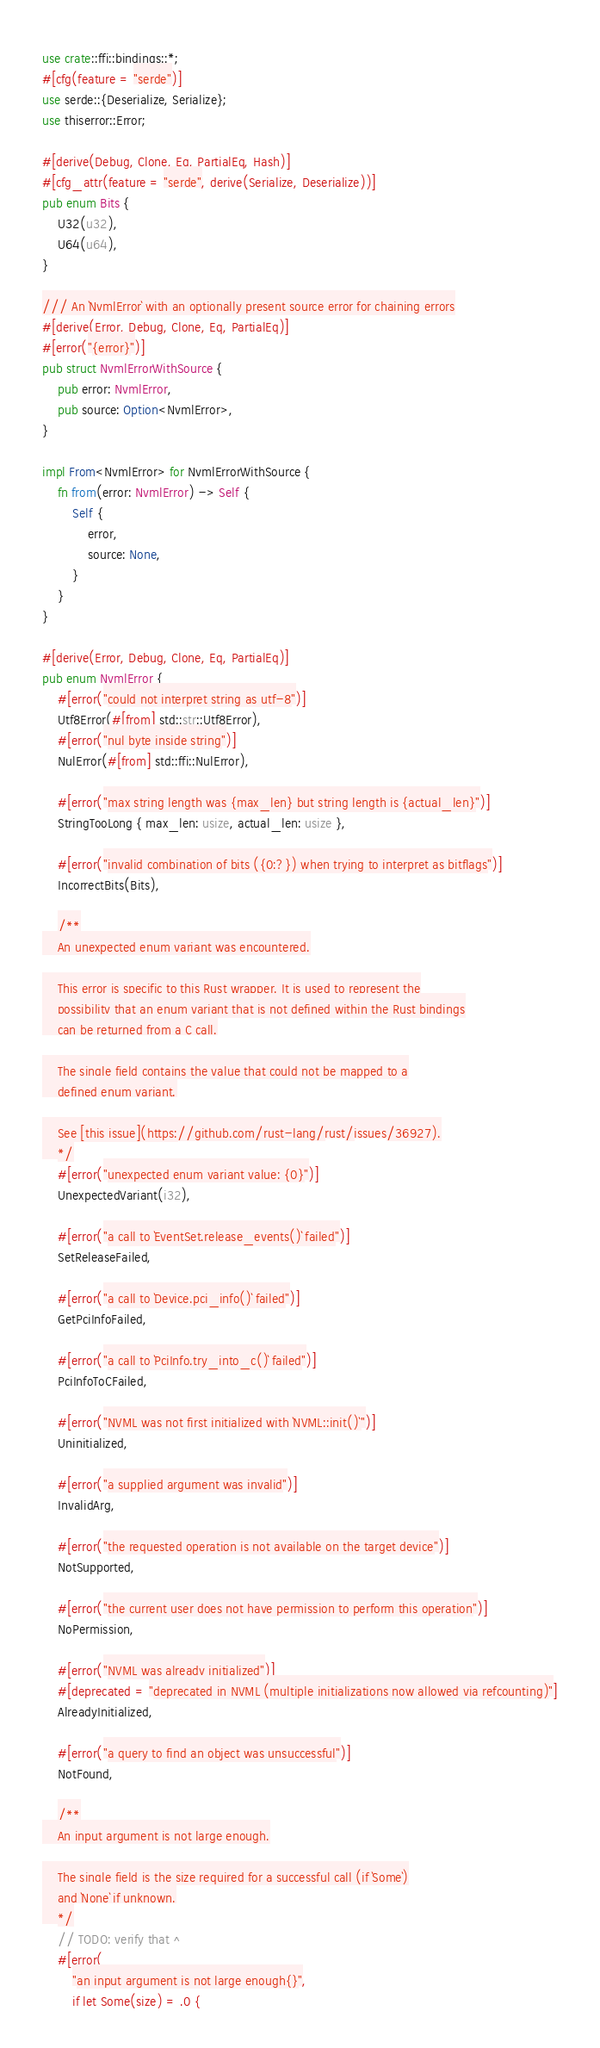Convert code to text. <code><loc_0><loc_0><loc_500><loc_500><_Rust_>use crate::ffi::bindings::*;
#[cfg(feature = "serde")]
use serde::{Deserialize, Serialize};
use thiserror::Error;

#[derive(Debug, Clone, Eq, PartialEq, Hash)]
#[cfg_attr(feature = "serde", derive(Serialize, Deserialize))]
pub enum Bits {
    U32(u32),
    U64(u64),
}

/// An `NvmlError` with an optionally present source error for chaining errors
#[derive(Error, Debug, Clone, Eq, PartialEq)]
#[error("{error}")]
pub struct NvmlErrorWithSource {
    pub error: NvmlError,
    pub source: Option<NvmlError>,
}

impl From<NvmlError> for NvmlErrorWithSource {
    fn from(error: NvmlError) -> Self {
        Self {
            error,
            source: None,
        }
    }
}

#[derive(Error, Debug, Clone, Eq, PartialEq)]
pub enum NvmlError {
    #[error("could not interpret string as utf-8")]
    Utf8Error(#[from] std::str::Utf8Error),
    #[error("nul byte inside string")]
    NulError(#[from] std::ffi::NulError),

    #[error("max string length was {max_len} but string length is {actual_len}")]
    StringTooLong { max_len: usize, actual_len: usize },

    #[error("invalid combination of bits ({0:?}) when trying to interpret as bitflags")]
    IncorrectBits(Bits),

    /**
    An unexpected enum variant was encountered.

    This error is specific to this Rust wrapper. It is used to represent the
    possibility that an enum variant that is not defined within the Rust bindings
    can be returned from a C call.

    The single field contains the value that could not be mapped to a
    defined enum variant.

    See [this issue](https://github.com/rust-lang/rust/issues/36927).
    */
    #[error("unexpected enum variant value: {0}")]
    UnexpectedVariant(i32),

    #[error("a call to `EventSet.release_events()` failed")]
    SetReleaseFailed,

    #[error("a call to `Device.pci_info()` failed")]
    GetPciInfoFailed,

    #[error("a call to `PciInfo.try_into_c()` failed")]
    PciInfoToCFailed,

    #[error("NVML was not first initialized with `NVML::init()`")]
    Uninitialized,

    #[error("a supplied argument was invalid")]
    InvalidArg,

    #[error("the requested operation is not available on the target device")]
    NotSupported,

    #[error("the current user does not have permission to perform this operation")]
    NoPermission,

    #[error("NVML was already initialized")]
    #[deprecated = "deprecated in NVML (multiple initializations now allowed via refcounting)"]
    AlreadyInitialized,

    #[error("a query to find an object was unsuccessful")]
    NotFound,

    /**
    An input argument is not large enough.

    The single field is the size required for a successful call (if `Some`)
    and `None` if unknown.
    */
    // TODO: verify that ^
    #[error(
        "an input argument is not large enough{}",
        if let Some(size) = .0 {</code> 